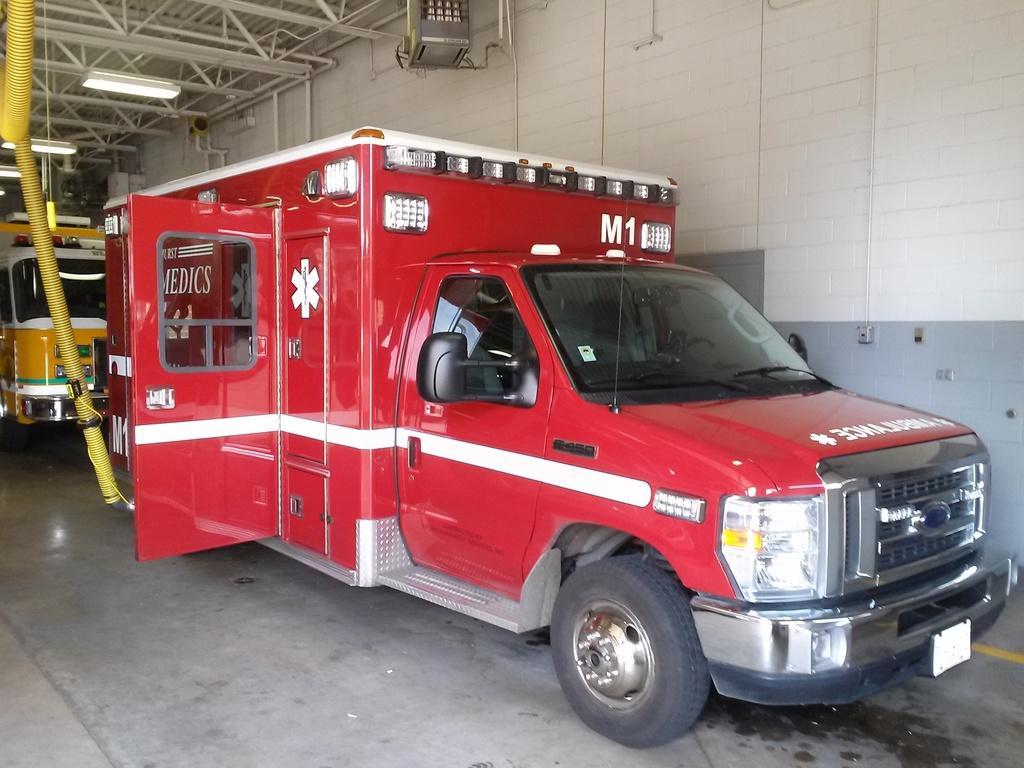How would you summarize this image in a sentence or two? In the picture I can see vehicles on the floor. In the background I can see a wall, lights on the ceiling and some other things. 